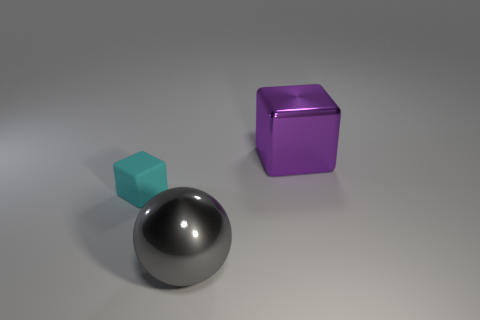What is the material of the thing that is the same size as the gray metallic ball?
Your answer should be very brief. Metal. What is the thing that is both behind the big gray shiny object and on the left side of the purple cube made of?
Provide a short and direct response. Rubber. Are any big gray metal balls visible?
Your answer should be compact. Yes. Are there any other things that are the same shape as the gray thing?
Your answer should be compact. No. There is a metallic thing that is in front of the block left of the large thing that is to the right of the big gray metallic sphere; what shape is it?
Ensure brevity in your answer.  Sphere. There is a tiny cyan matte thing; what shape is it?
Offer a terse response. Cube. What color is the thing that is in front of the small cyan matte object?
Your response must be concise. Gray. There is a thing left of the gray metallic thing; is it the same size as the gray thing?
Your answer should be very brief. No. What size is the other matte thing that is the same shape as the purple object?
Ensure brevity in your answer.  Small. Are there any other things that are the same size as the cyan thing?
Offer a very short reply. No. 